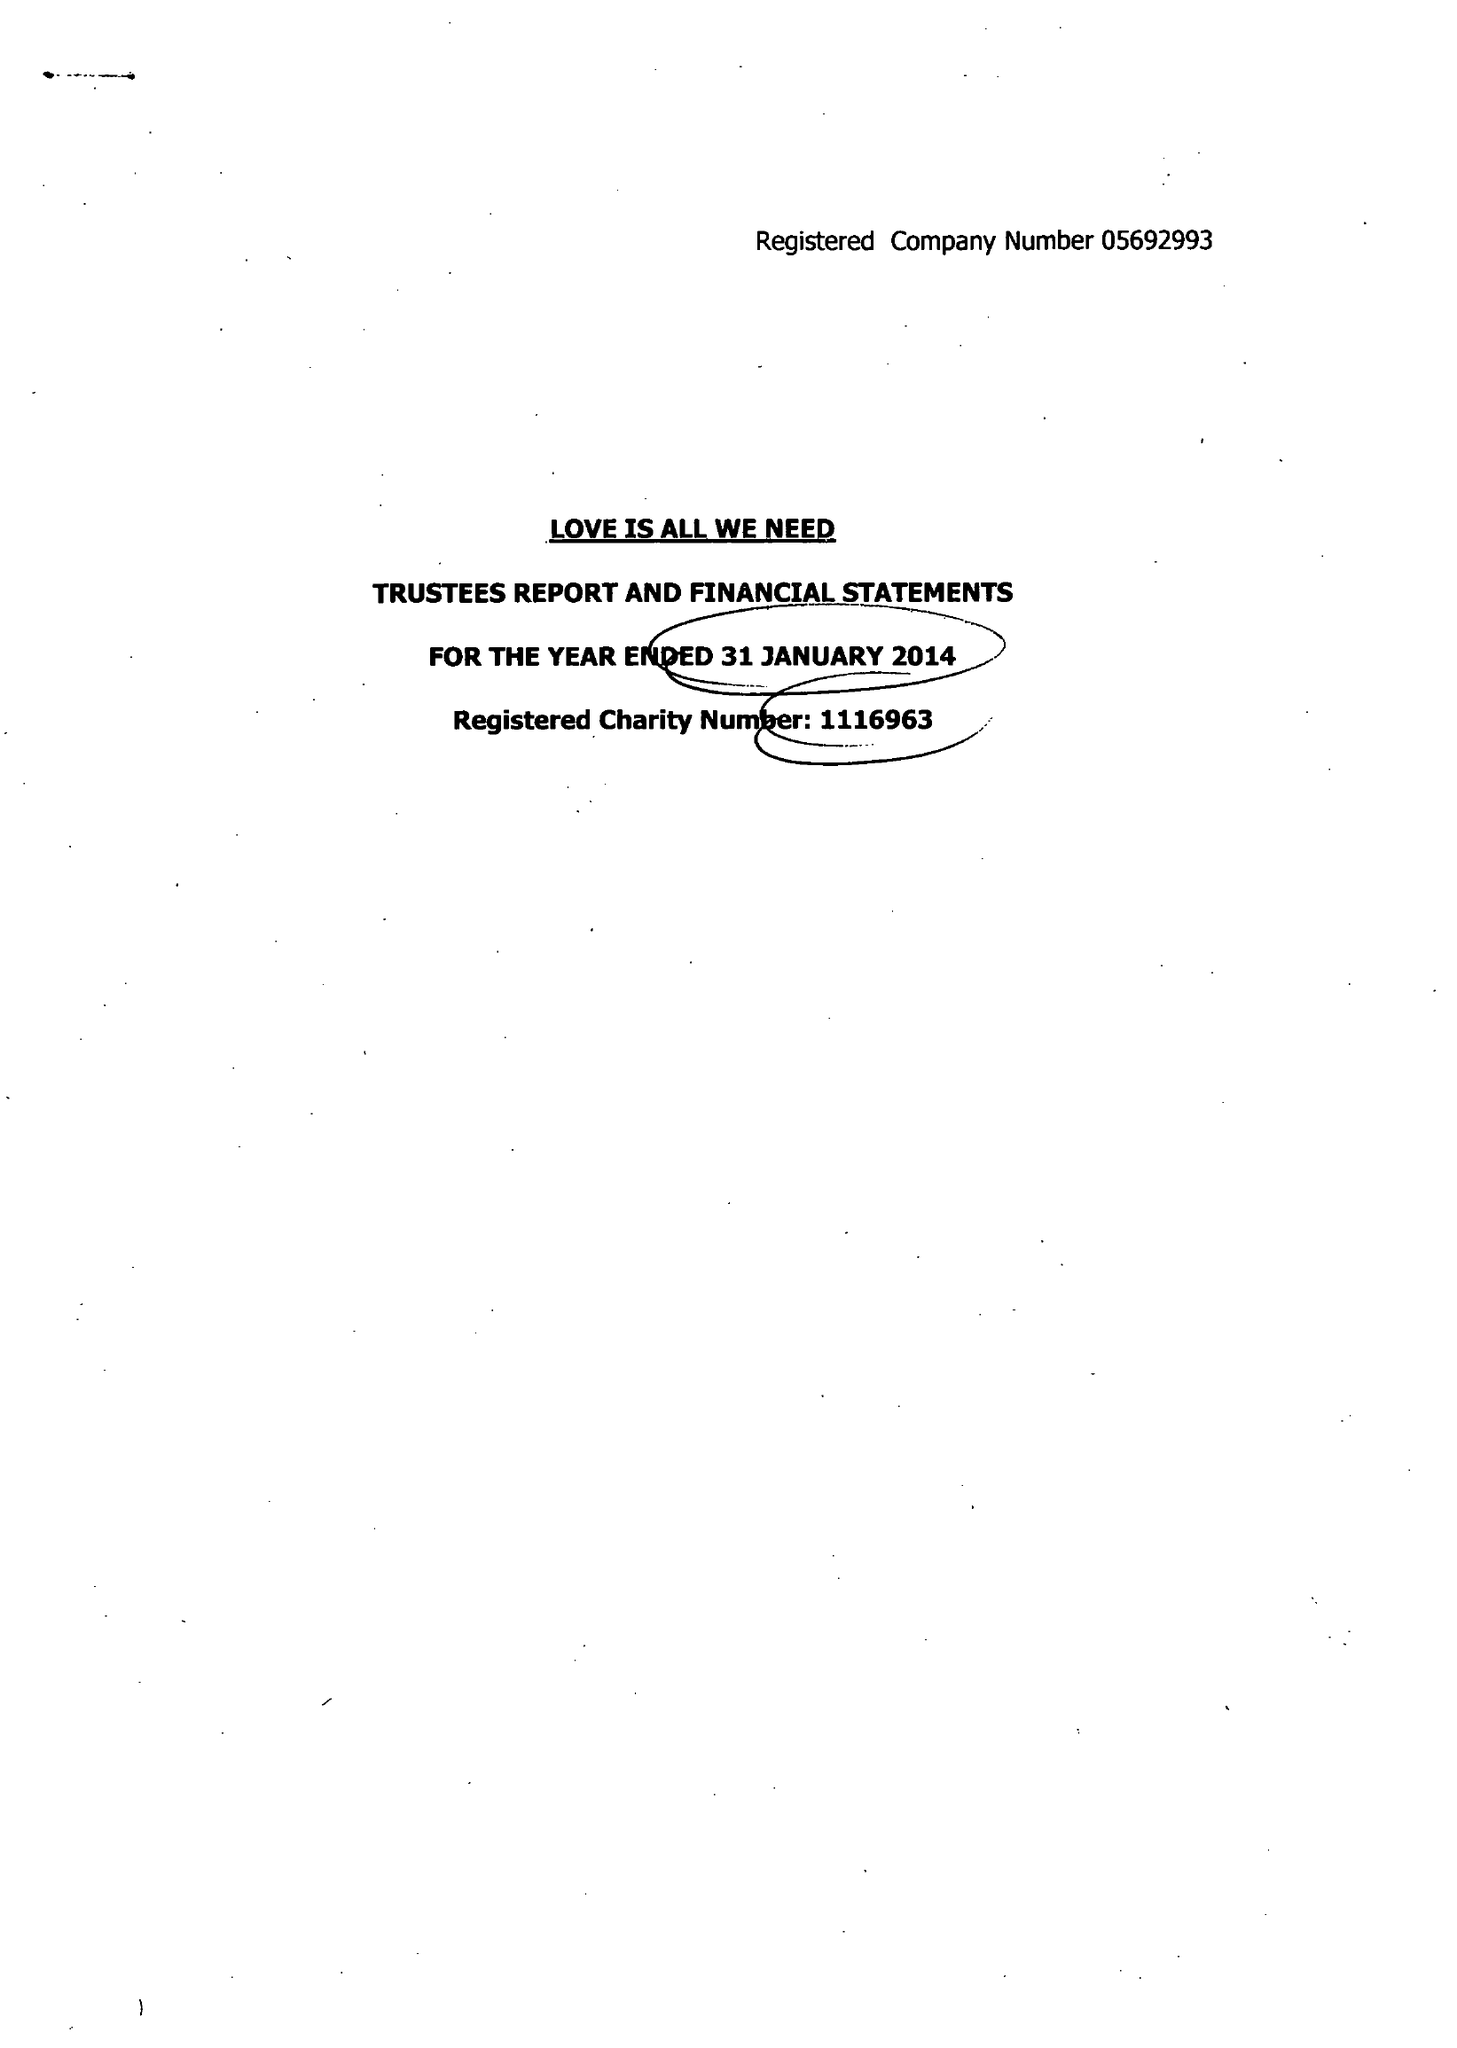What is the value for the income_annually_in_british_pounds?
Answer the question using a single word or phrase. 33168.00 